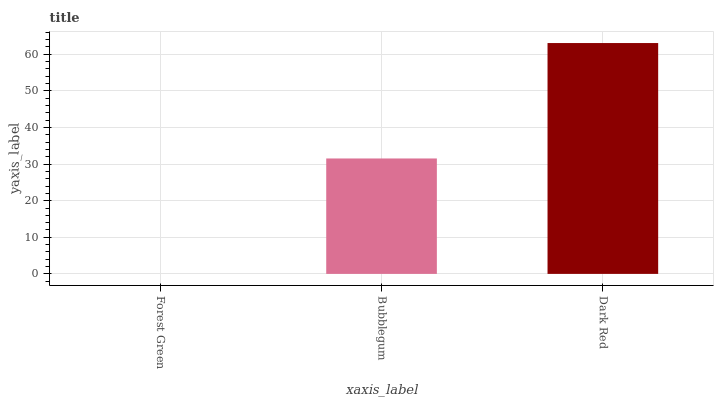Is Forest Green the minimum?
Answer yes or no. Yes. Is Dark Red the maximum?
Answer yes or no. Yes. Is Bubblegum the minimum?
Answer yes or no. No. Is Bubblegum the maximum?
Answer yes or no. No. Is Bubblegum greater than Forest Green?
Answer yes or no. Yes. Is Forest Green less than Bubblegum?
Answer yes or no. Yes. Is Forest Green greater than Bubblegum?
Answer yes or no. No. Is Bubblegum less than Forest Green?
Answer yes or no. No. Is Bubblegum the high median?
Answer yes or no. Yes. Is Bubblegum the low median?
Answer yes or no. Yes. Is Forest Green the high median?
Answer yes or no. No. Is Forest Green the low median?
Answer yes or no. No. 